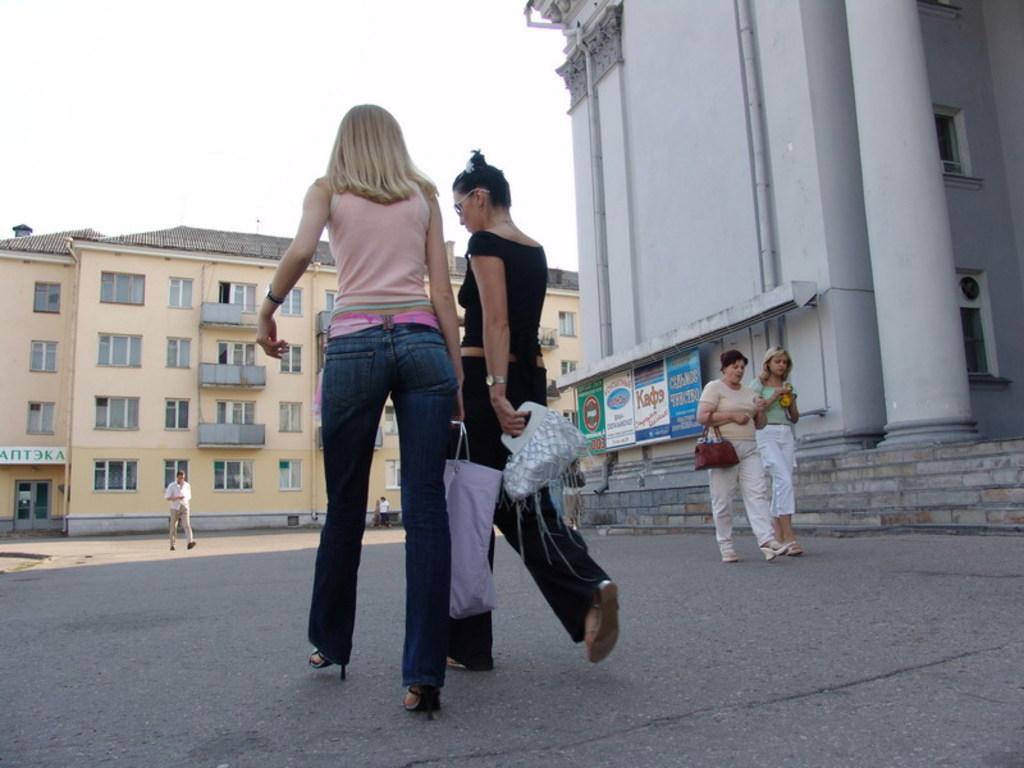Can you describe this image briefly? In the image there are some people walking on the ground and there are two big buildings around the people. In the front there are two women walking on the ground they are carrying bags in their hand. 